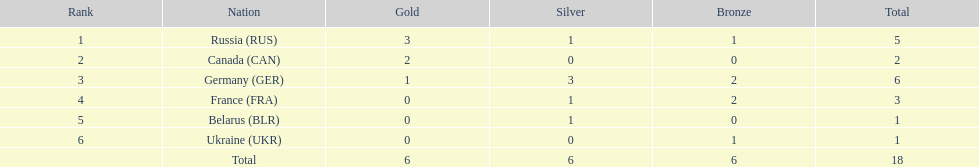What is the count of silver medals won by belarus? 1. 